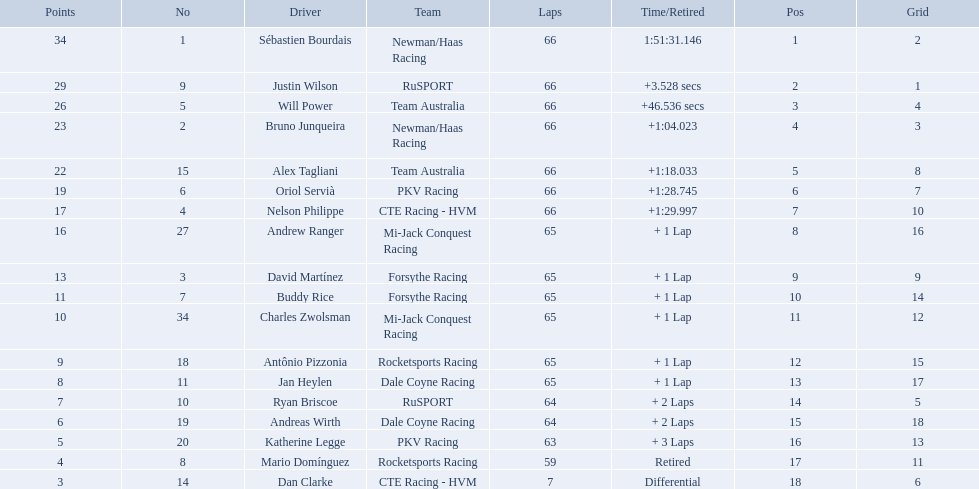What was the highest amount of points scored in the 2006 gran premio? 34. Who scored 34 points? Sébastien Bourdais. 